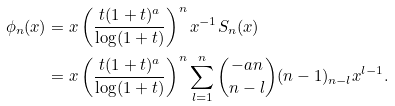Convert formula to latex. <formula><loc_0><loc_0><loc_500><loc_500>\phi _ { n } ( x ) & = x \left ( \frac { t ( 1 + t ) ^ { a } } { \log ( 1 + t ) } \right ) ^ { n } x ^ { - 1 } S _ { n } ( x ) \\ & = x \left ( \frac { t ( 1 + t ) ^ { a } } { \log ( 1 + t ) } \right ) ^ { n } \sum _ { l = 1 } ^ { n } \binom { - a n } { n - l } ( n - 1 ) _ { n - l } x ^ { l - 1 } .</formula> 